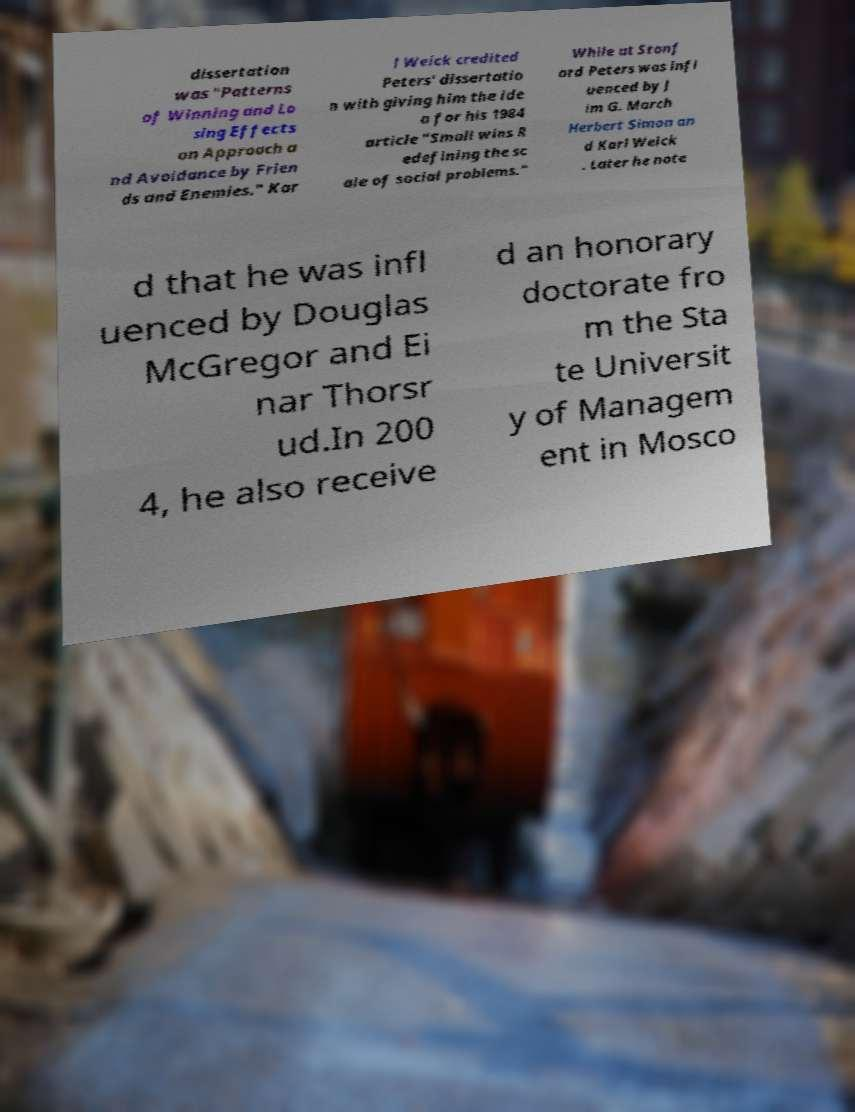Can you accurately transcribe the text from the provided image for me? dissertation was "Patterns of Winning and Lo sing Effects on Approach a nd Avoidance by Frien ds and Enemies." Kar l Weick credited Peters' dissertatio n with giving him the ide a for his 1984 article "Small wins R edefining the sc ale of social problems." While at Stanf ord Peters was infl uenced by J im G. March Herbert Simon an d Karl Weick . Later he note d that he was infl uenced by Douglas McGregor and Ei nar Thorsr ud.In 200 4, he also receive d an honorary doctorate fro m the Sta te Universit y of Managem ent in Mosco 